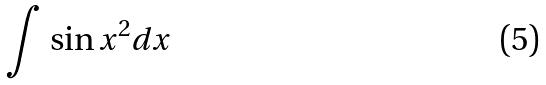<formula> <loc_0><loc_0><loc_500><loc_500>\int \sin x ^ { 2 } d x</formula> 